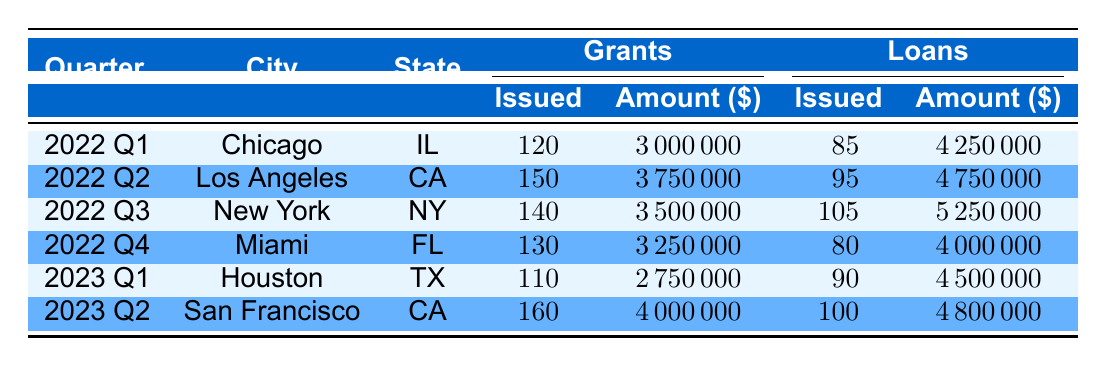What city received the highest total grant amount? By reviewing the "Total Grant Amount" column, we see the values are as follows: Chicago: 3,000,000, Los Angeles: 3,750,000, New York: 3,500,000, Miami: 3,250,000, Houston: 2,750,000, San Francisco: 4,000,000. The highest amount is for San Francisco, which received 4,000,000.
Answer: San Francisco How many loans were issued in 2022 Q3? From the table, in 2022 Q3, the "Loans Issued" column shows that New York had 105 loans issued.
Answer: 105 What is the total amount of grants issued across all quarters? To find the total grants, sum the values from the "Grants Issued" column: 120 (2022 Q1) + 150 (2022 Q2) + 140 (2022 Q3) + 130 (2022 Q4) + 110 (2023 Q1) + 160 (2023 Q2) = 1,010 grants issued in total.
Answer: 1010 Did Miami issue more loans than Chicago? In Miami (2022 Q4), 80 loans were issued while in Chicago (2022 Q1), 85 loans were issued. Since 80 is less than 85, Miami did not issue more loans.
Answer: No What is the average total loan amount issued per quarter? To find the average, first sum the "Total Loan Amount" values: 4,250,000 (Chicago) + 4,750,000 (Los Angeles) + 5,250,000 (New York) + 4,000,000 (Miami) + 4,500,000 (Houston) + 4,800,000 (San Francisco) = 27,500,000. Then divide by the number of quarters (6): 27,500,000 / 6 = 4,583,333.33.
Answer: 4,583,333.33 Which quarter saw the least number of grants issued? Looking through the "Grants Issued" values: 120 (Q1), 150 (Q2), 140 (Q3), 130 (Q4), 110 (Q1 of 2023), and 160 (Q2 of 2023), it's clear that the least number of grants issued was 110 in Houston for 2023 Q1.
Answer: 2023 Q1 